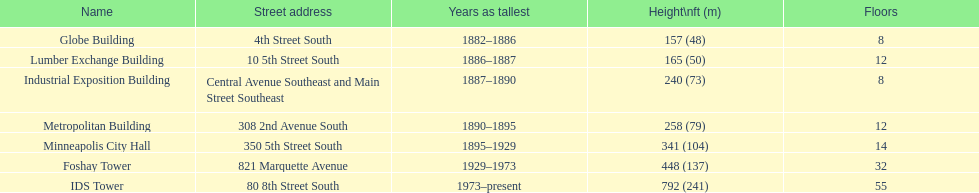Which structure consists of 8 levels and has a height of 240 feet? Industrial Exposition Building. 